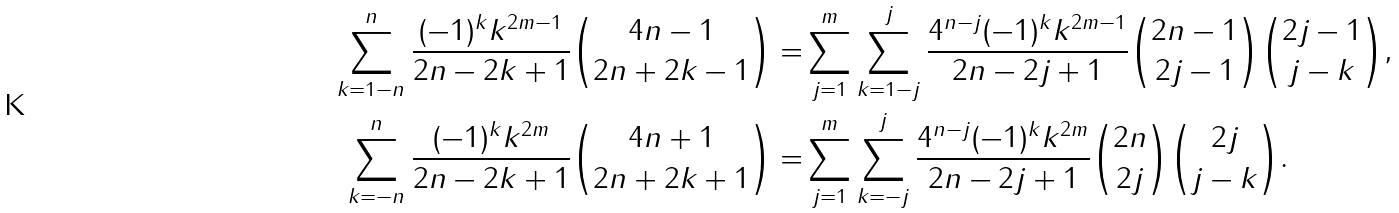<formula> <loc_0><loc_0><loc_500><loc_500>\sum _ { k = 1 - n } ^ { n } \frac { ( - 1 ) ^ { k } k ^ { 2 m - 1 } } { 2 n - 2 k + 1 } { 4 n - 1 \choose 2 n + 2 k - 1 } = & \sum _ { j = 1 } ^ { m } \sum _ { k = 1 - j } ^ { j } \frac { 4 ^ { n - j } ( - 1 ) ^ { k } k ^ { 2 m - 1 } } { 2 n - 2 j + 1 } { 2 n - 1 \choose 2 j - 1 } { 2 j - 1 \choose j - k } , \\ \sum _ { k = - n } ^ { n } \frac { ( - 1 ) ^ { k } k ^ { 2 m } } { 2 n - 2 k + 1 } { 4 n + 1 \choose 2 n + 2 k + 1 } = & \sum _ { j = 1 } ^ { m } \sum _ { k = - j } ^ { j } \frac { 4 ^ { n - j } ( - 1 ) ^ { k } k ^ { 2 m } } { 2 n - 2 j + 1 } { 2 n \choose 2 j } { 2 j \choose j - k } .</formula> 